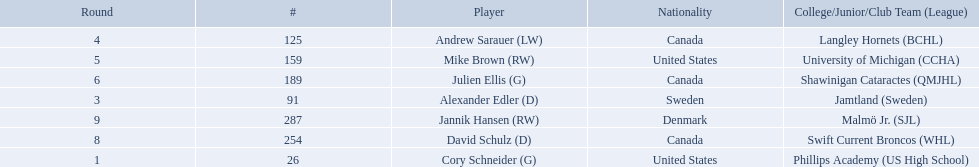Who were the players in the 2004-05 vancouver canucks season Cory Schneider (G), Alexander Edler (D), Andrew Sarauer (LW), Mike Brown (RW), Julien Ellis (G), David Schulz (D), Jannik Hansen (RW). Can you give me this table as a dict? {'header': ['Round', '#', 'Player', 'Nationality', 'College/Junior/Club Team (League)'], 'rows': [['4', '125', 'Andrew Sarauer (LW)', 'Canada', 'Langley Hornets (BCHL)'], ['5', '159', 'Mike Brown (RW)', 'United States', 'University of Michigan (CCHA)'], ['6', '189', 'Julien Ellis (G)', 'Canada', 'Shawinigan Cataractes (QMJHL)'], ['3', '91', 'Alexander Edler (D)', 'Sweden', 'Jamtland (Sweden)'], ['9', '287', 'Jannik Hansen (RW)', 'Denmark', 'Malmö Jr. (SJL)'], ['8', '254', 'David Schulz (D)', 'Canada', 'Swift Current Broncos (WHL)'], ['1', '26', 'Cory Schneider (G)', 'United States', 'Phillips Academy (US High School)']]} Of these players who had a nationality of denmark? Jannik Hansen (RW). 